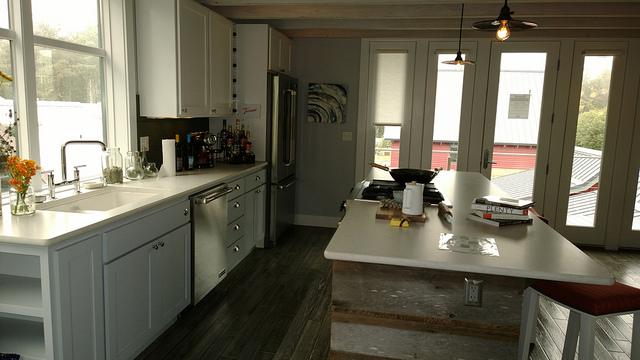What is the primary color of the room?
Concise answer only. White. Is this the kitchen area?
Give a very brief answer. Yes. Which room is this?
Give a very brief answer. Kitchen. 